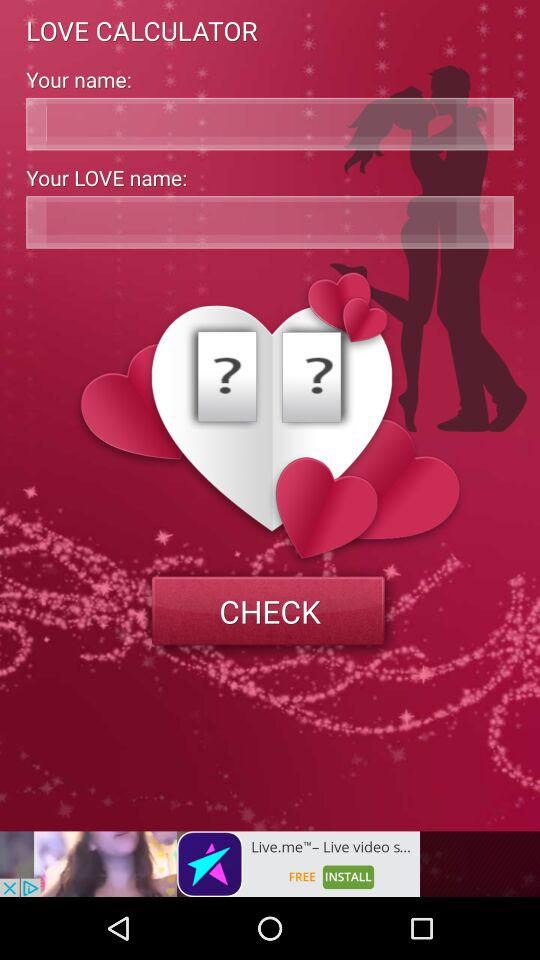What is the application name? The application name is "LOVE CALCULATOR". 